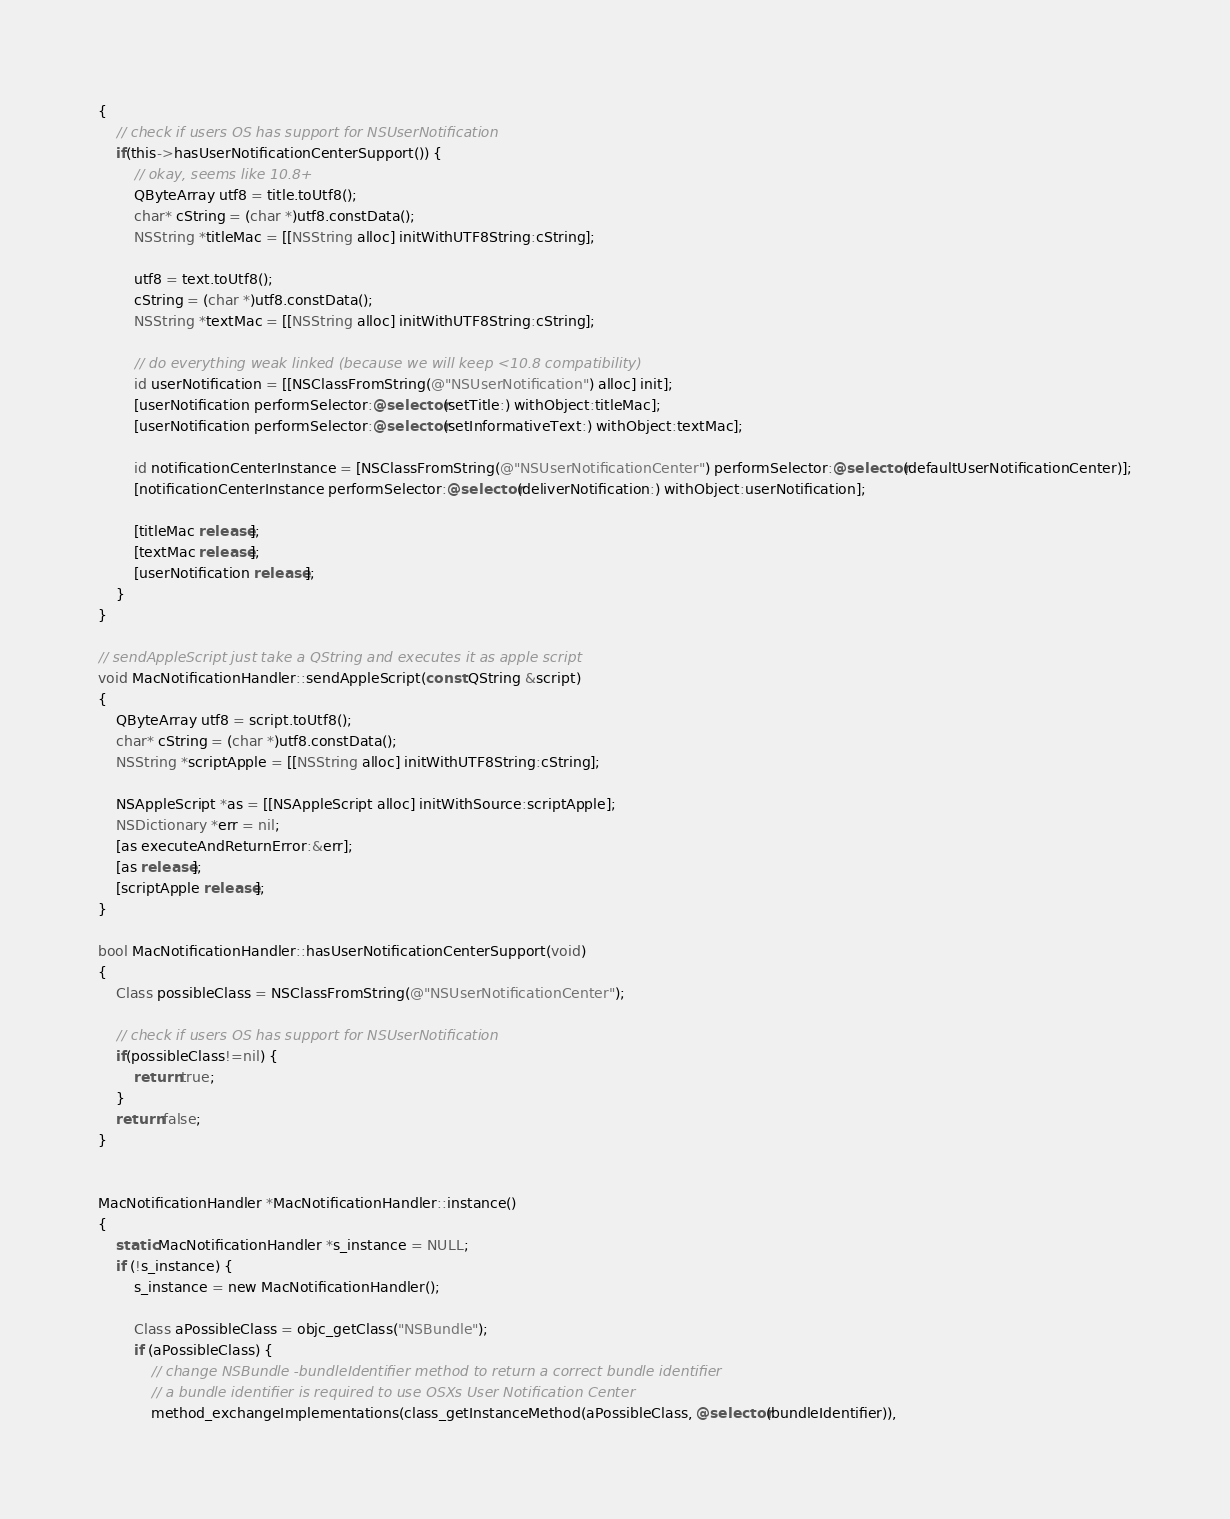Convert code to text. <code><loc_0><loc_0><loc_500><loc_500><_ObjectiveC_>{
    // check if users OS has support for NSUserNotification
    if(this->hasUserNotificationCenterSupport()) {
        // okay, seems like 10.8+
        QByteArray utf8 = title.toUtf8();
        char* cString = (char *)utf8.constData();
        NSString *titleMac = [[NSString alloc] initWithUTF8String:cString];

        utf8 = text.toUtf8();
        cString = (char *)utf8.constData();
        NSString *textMac = [[NSString alloc] initWithUTF8String:cString];

        // do everything weak linked (because we will keep <10.8 compatibility)
        id userNotification = [[NSClassFromString(@"NSUserNotification") alloc] init];
        [userNotification performSelector:@selector(setTitle:) withObject:titleMac];
        [userNotification performSelector:@selector(setInformativeText:) withObject:textMac];

        id notificationCenterInstance = [NSClassFromString(@"NSUserNotificationCenter") performSelector:@selector(defaultUserNotificationCenter)];
        [notificationCenterInstance performSelector:@selector(deliverNotification:) withObject:userNotification];

        [titleMac release];
        [textMac release];
        [userNotification release];
    }
}

// sendAppleScript just take a QString and executes it as apple script
void MacNotificationHandler::sendAppleScript(const QString &script)
{
    QByteArray utf8 = script.toUtf8();
    char* cString = (char *)utf8.constData();
    NSString *scriptApple = [[NSString alloc] initWithUTF8String:cString];

    NSAppleScript *as = [[NSAppleScript alloc] initWithSource:scriptApple];
    NSDictionary *err = nil;
    [as executeAndReturnError:&err];
    [as release];
    [scriptApple release];
}

bool MacNotificationHandler::hasUserNotificationCenterSupport(void)
{
    Class possibleClass = NSClassFromString(@"NSUserNotificationCenter");

    // check if users OS has support for NSUserNotification
    if(possibleClass!=nil) {
        return true;
    }
    return false;
}


MacNotificationHandler *MacNotificationHandler::instance()
{
    static MacNotificationHandler *s_instance = NULL;
    if (!s_instance) {
        s_instance = new MacNotificationHandler();
        
        Class aPossibleClass = objc_getClass("NSBundle");
        if (aPossibleClass) {
            // change NSBundle -bundleIdentifier method to return a correct bundle identifier
            // a bundle identifier is required to use OSXs User Notification Center
            method_exchangeImplementations(class_getInstanceMethod(aPossibleClass, @selector(bundleIdentifier)),</code> 